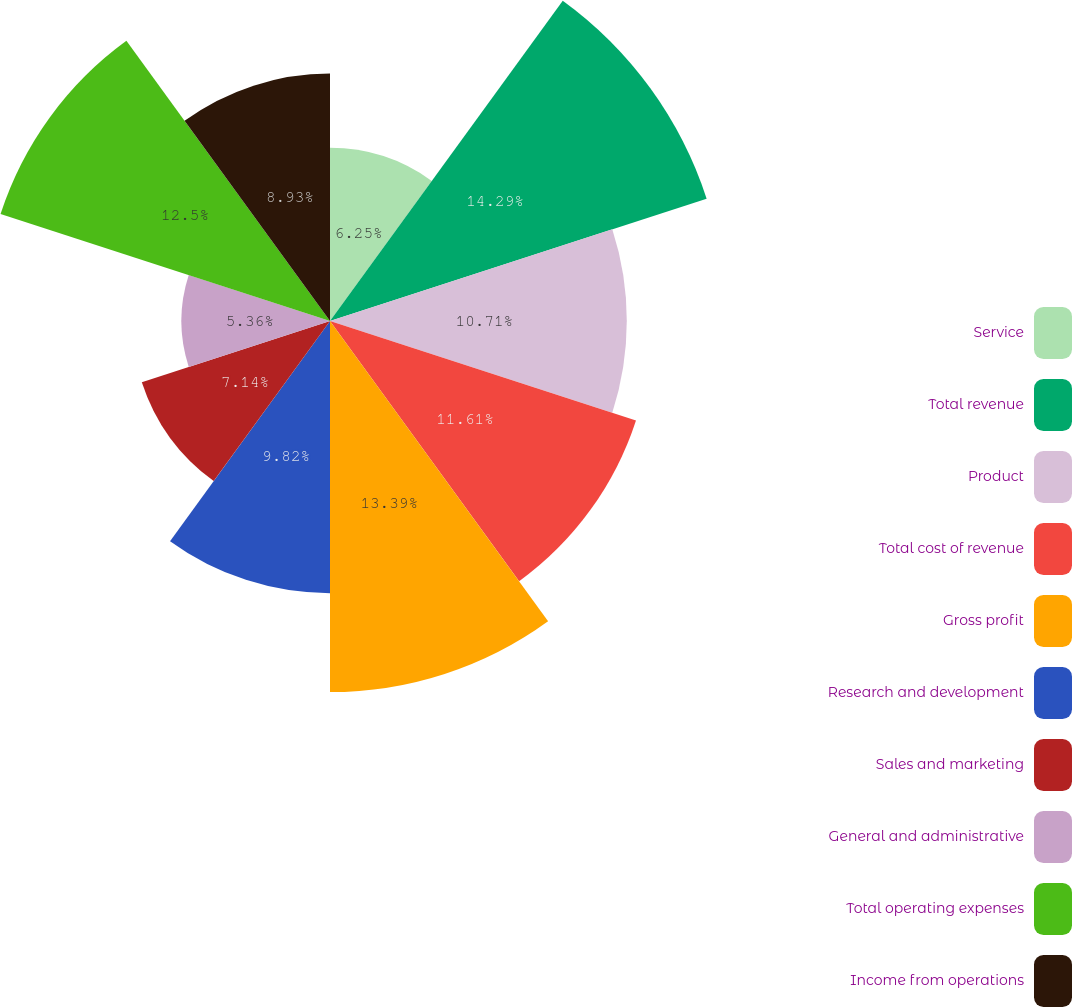Convert chart. <chart><loc_0><loc_0><loc_500><loc_500><pie_chart><fcel>Service<fcel>Total revenue<fcel>Product<fcel>Total cost of revenue<fcel>Gross profit<fcel>Research and development<fcel>Sales and marketing<fcel>General and administrative<fcel>Total operating expenses<fcel>Income from operations<nl><fcel>6.25%<fcel>14.29%<fcel>10.71%<fcel>11.61%<fcel>13.39%<fcel>9.82%<fcel>7.14%<fcel>5.36%<fcel>12.5%<fcel>8.93%<nl></chart> 